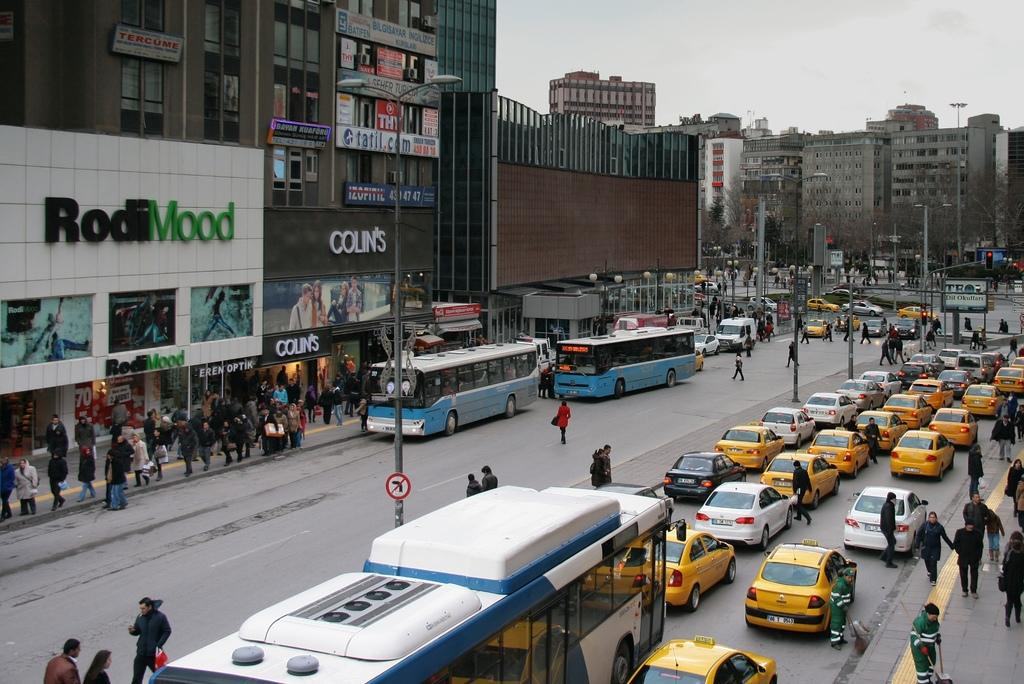<image>
Write a terse but informative summary of the picture. A street with buses and taxis with a RodiMood and a Colin's in the background. 